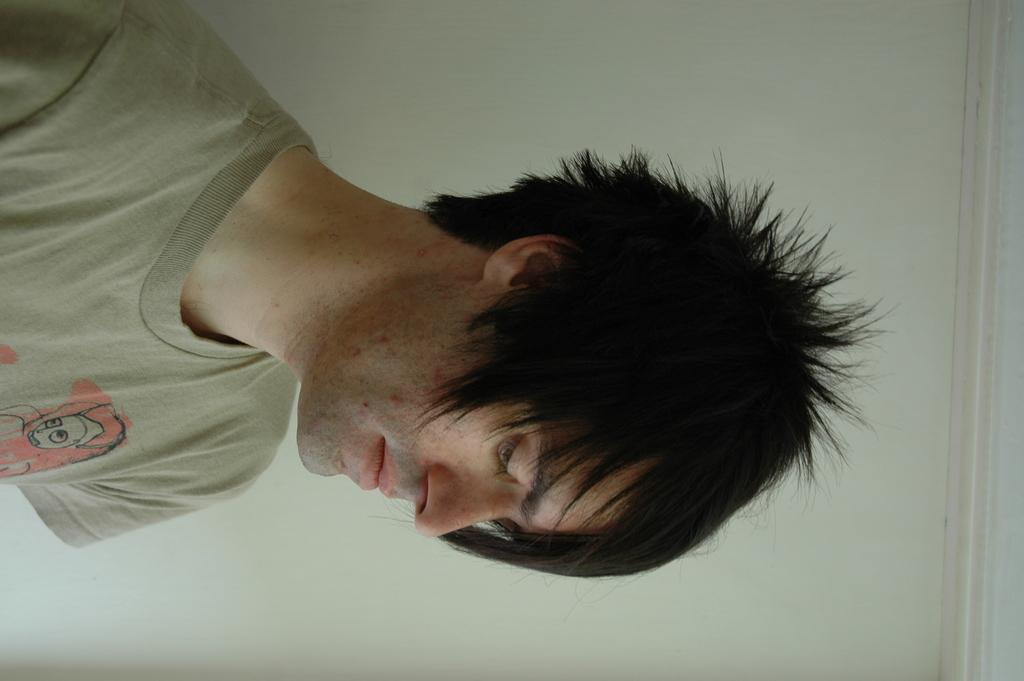What can be seen in the image? There is a person in the image. What is the person wearing? The person is wearing a cream color T-shirt. What can be seen in the background of the image? There is a white color wall in the background of the image. What sound does the thunder make in the image? There is no thunder present in the image, so it cannot make any sound. 